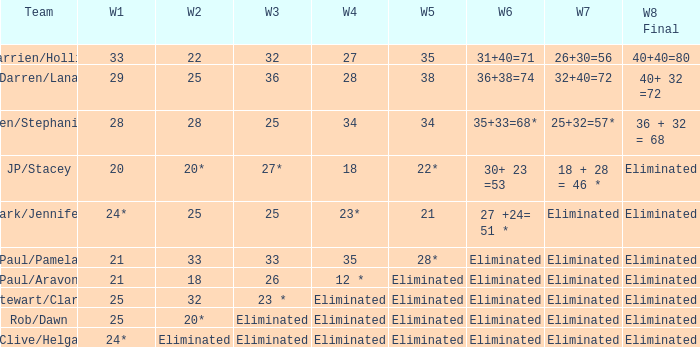Name the team for week 1 of 33 Darrien/Hollie. Can you give me this table as a dict? {'header': ['Team', 'W1', 'W2', 'W3', 'W4', 'W5', 'W6', 'W7', 'W8 Final'], 'rows': [['Darrien/Hollie', '33', '22', '32', '27', '35', '31+40=71', '26+30=56', '40+40=80'], ['Darren/Lana', '29', '25', '36', '28', '38', '36+38=74', '32+40=72', '40+ 32 =72'], ['Ben/Stephanie', '28', '28', '25', '34', '34', '35+33=68*', '25+32=57*', '36 + 32 = 68'], ['JP/Stacey', '20', '20*', '27*', '18', '22*', '30+ 23 =53', '18 + 28 = 46 *', 'Eliminated'], ['Mark/Jennifer', '24*', '25', '25', '23*', '21', '27 +24= 51 *', 'Eliminated', 'Eliminated'], ['Paul/Pamela', '21', '33', '33', '35', '28*', 'Eliminated', 'Eliminated', 'Eliminated'], ['Paul/Aravon', '21', '18', '26', '12 *', 'Eliminated', 'Eliminated', 'Eliminated', 'Eliminated'], ['Stewart/Clare', '25', '32', '23 *', 'Eliminated', 'Eliminated', 'Eliminated', 'Eliminated', 'Eliminated'], ['Rob/Dawn', '25', '20*', 'Eliminated', 'Eliminated', 'Eliminated', 'Eliminated', 'Eliminated', 'Eliminated'], ['Clive/Helga', '24*', 'Eliminated', 'Eliminated', 'Eliminated', 'Eliminated', 'Eliminated', 'Eliminated', 'Eliminated']]} 